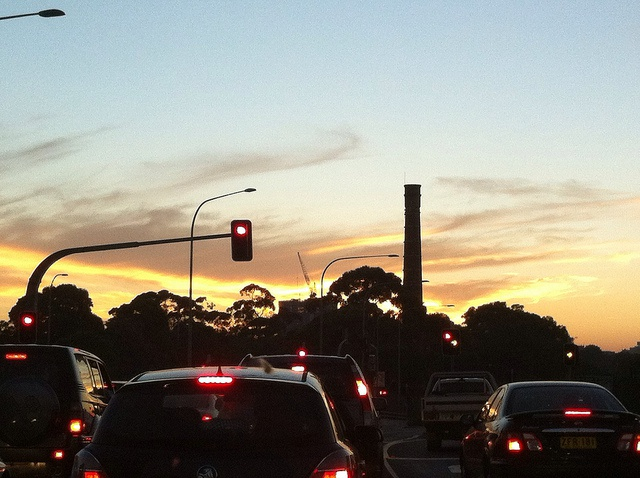Describe the objects in this image and their specific colors. I can see car in lightblue, black, gray, maroon, and darkgray tones, car in lightblue, black, gray, maroon, and tan tones, car in lightblue, black, maroon, gray, and brown tones, car in lightblue, black, maroon, gray, and white tones, and truck in lightblue, black, gray, and maroon tones in this image. 